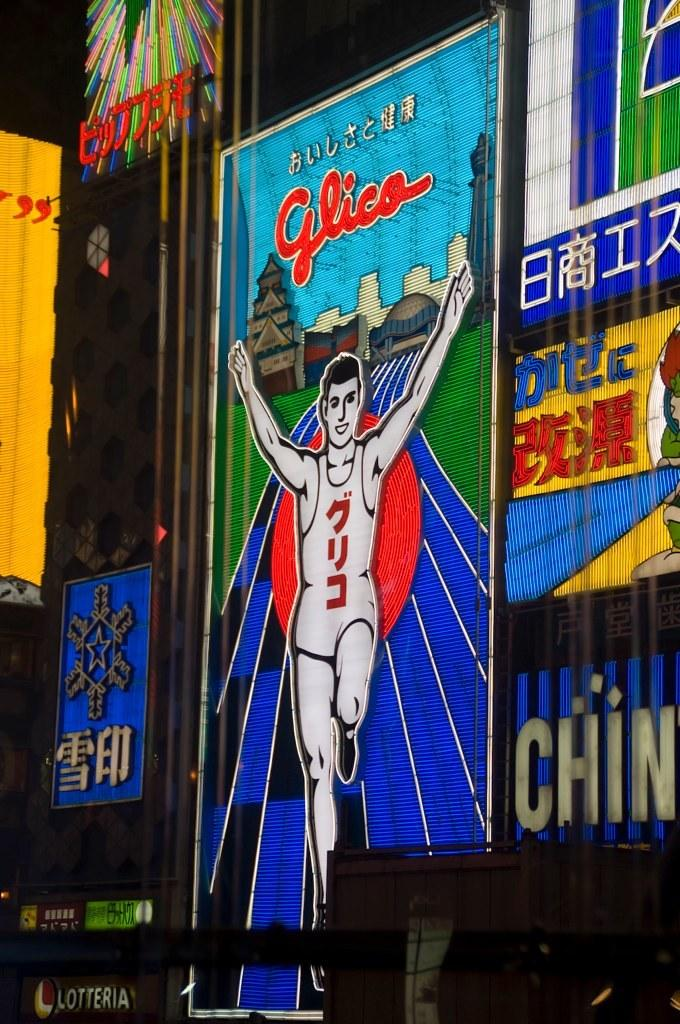<image>
Describe the image concisely. A light-up sign reads "Glico" on the top. 